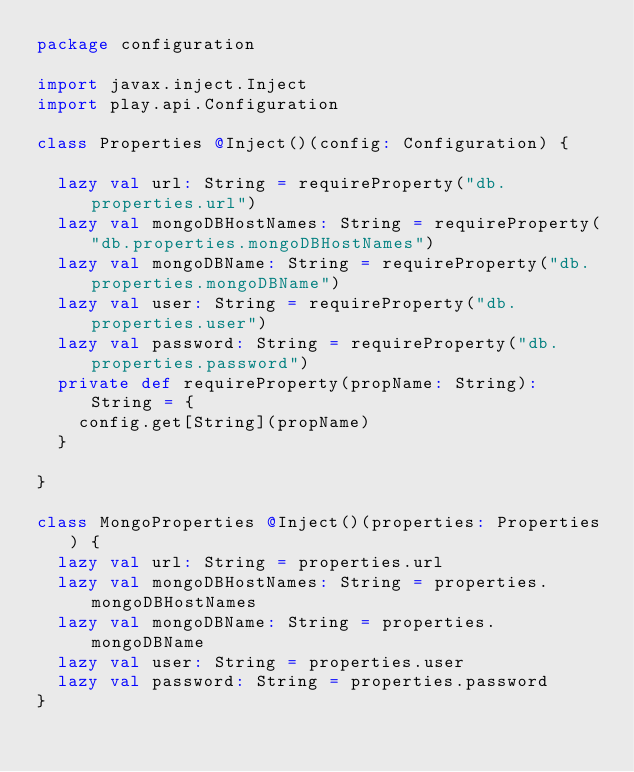<code> <loc_0><loc_0><loc_500><loc_500><_Scala_>package configuration

import javax.inject.Inject
import play.api.Configuration

class Properties @Inject()(config: Configuration) {

  lazy val url: String = requireProperty("db.properties.url")
  lazy val mongoDBHostNames: String = requireProperty("db.properties.mongoDBHostNames")
  lazy val mongoDBName: String = requireProperty("db.properties.mongoDBName")
  lazy val user: String = requireProperty("db.properties.user")
  lazy val password: String = requireProperty("db.properties.password")
  private def requireProperty(propName: String): String = {
    config.get[String](propName)
  }

}

class MongoProperties @Inject()(properties: Properties) {
  lazy val url: String = properties.url
  lazy val mongoDBHostNames: String = properties.mongoDBHostNames
  lazy val mongoDBName: String = properties.mongoDBName
  lazy val user: String = properties.user
  lazy val password: String = properties.password
}

</code> 